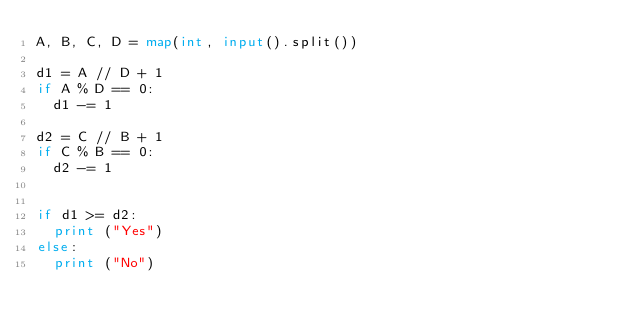<code> <loc_0><loc_0><loc_500><loc_500><_Python_>A, B, C, D = map(int, input().split())

d1 = A // D + 1
if A % D == 0:
  d1 -= 1

d2 = C // B + 1
if C % B == 0:
  d2 -= 1

  
if d1 >= d2:
  print ("Yes")
else:
  print ("No")</code> 